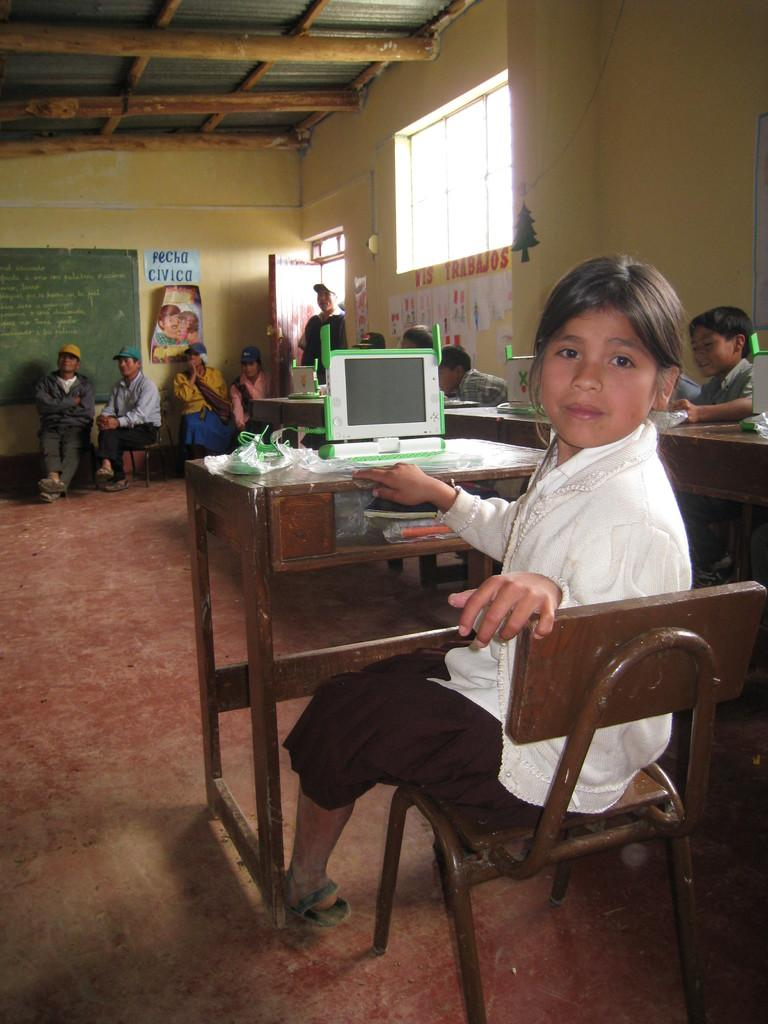What are the people in the image doing? The people in the image are sitting on chairs. What is in front of the chairs? There is a table in front of the chairs. What electronic device is on the table? A laptop is present on the table. What color is the wall visible in the image? There is a yellow-colored wall in the image. Can you see the heartbeat of the person sitting on the chair in the image? There is no indication of a person's heartbeat in the image, as it is not a medical examination or related to health monitoring. 